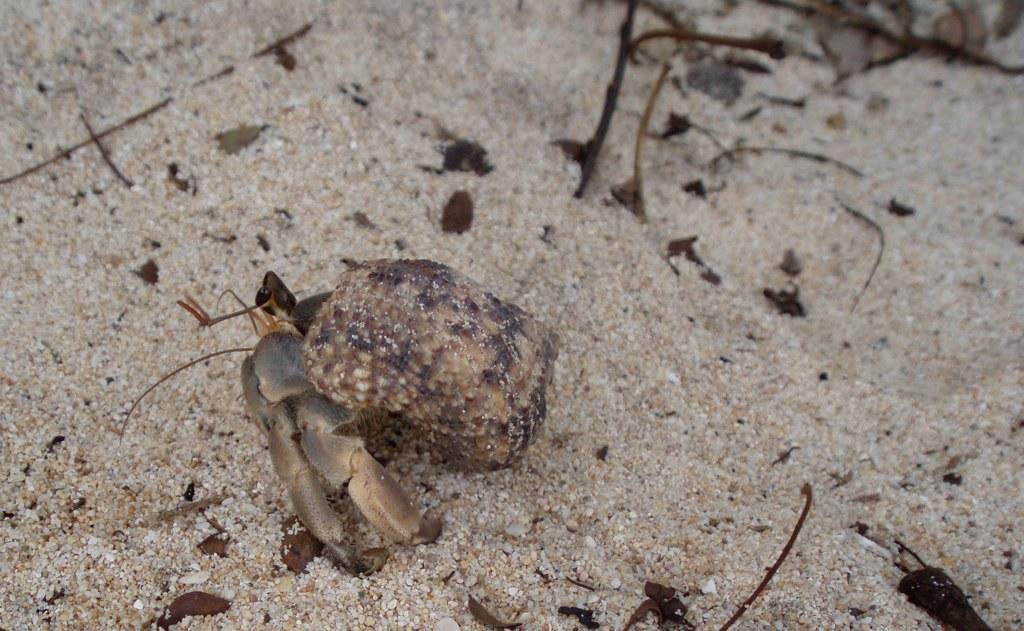What is the main subject of the image? There is an object (insert) in the image. Where is the object located? The object is on the sand. What type of ice can be seen melting around the object in the image? There is no ice present in the image; the object is on the sand. Can you tell me how many people are in a group agreement in the image? There is no group agreement or people present in the image; it only features an object on the sand. 